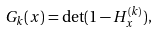<formula> <loc_0><loc_0><loc_500><loc_500>G _ { k } ( x ) = \det ( 1 - H _ { x } ^ { ( k ) } ) ,</formula> 